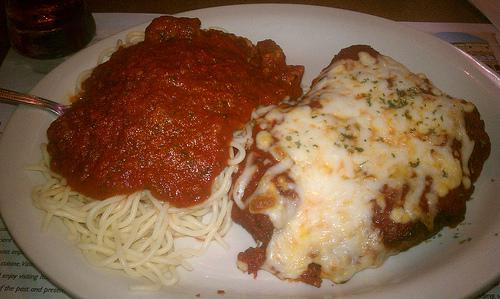Question: what is this?
Choices:
A. Food.
B. Water.
C. Beer.
D. Wine.
Answer with the letter. Answer: A Question: what color is the plate?
Choices:
A. Blue.
B. White.
C. Beige.
D. Yellow.
Answer with the letter. Answer: B Question: what type of food is this?
Choices:
A. Meat.
B. Cheese.
C. Pasta.
D. Bread.
Answer with the letter. Answer: C Question: who is present?
Choices:
A. Nobody.
B. One person.
C. Two people.
D. Three people.
Answer with the letter. Answer: A Question: where is this scene?
Choices:
A. At breakfast.
B. In the bedroom.
C. In the yard.
D. At the dinner table.
Answer with the letter. Answer: D 